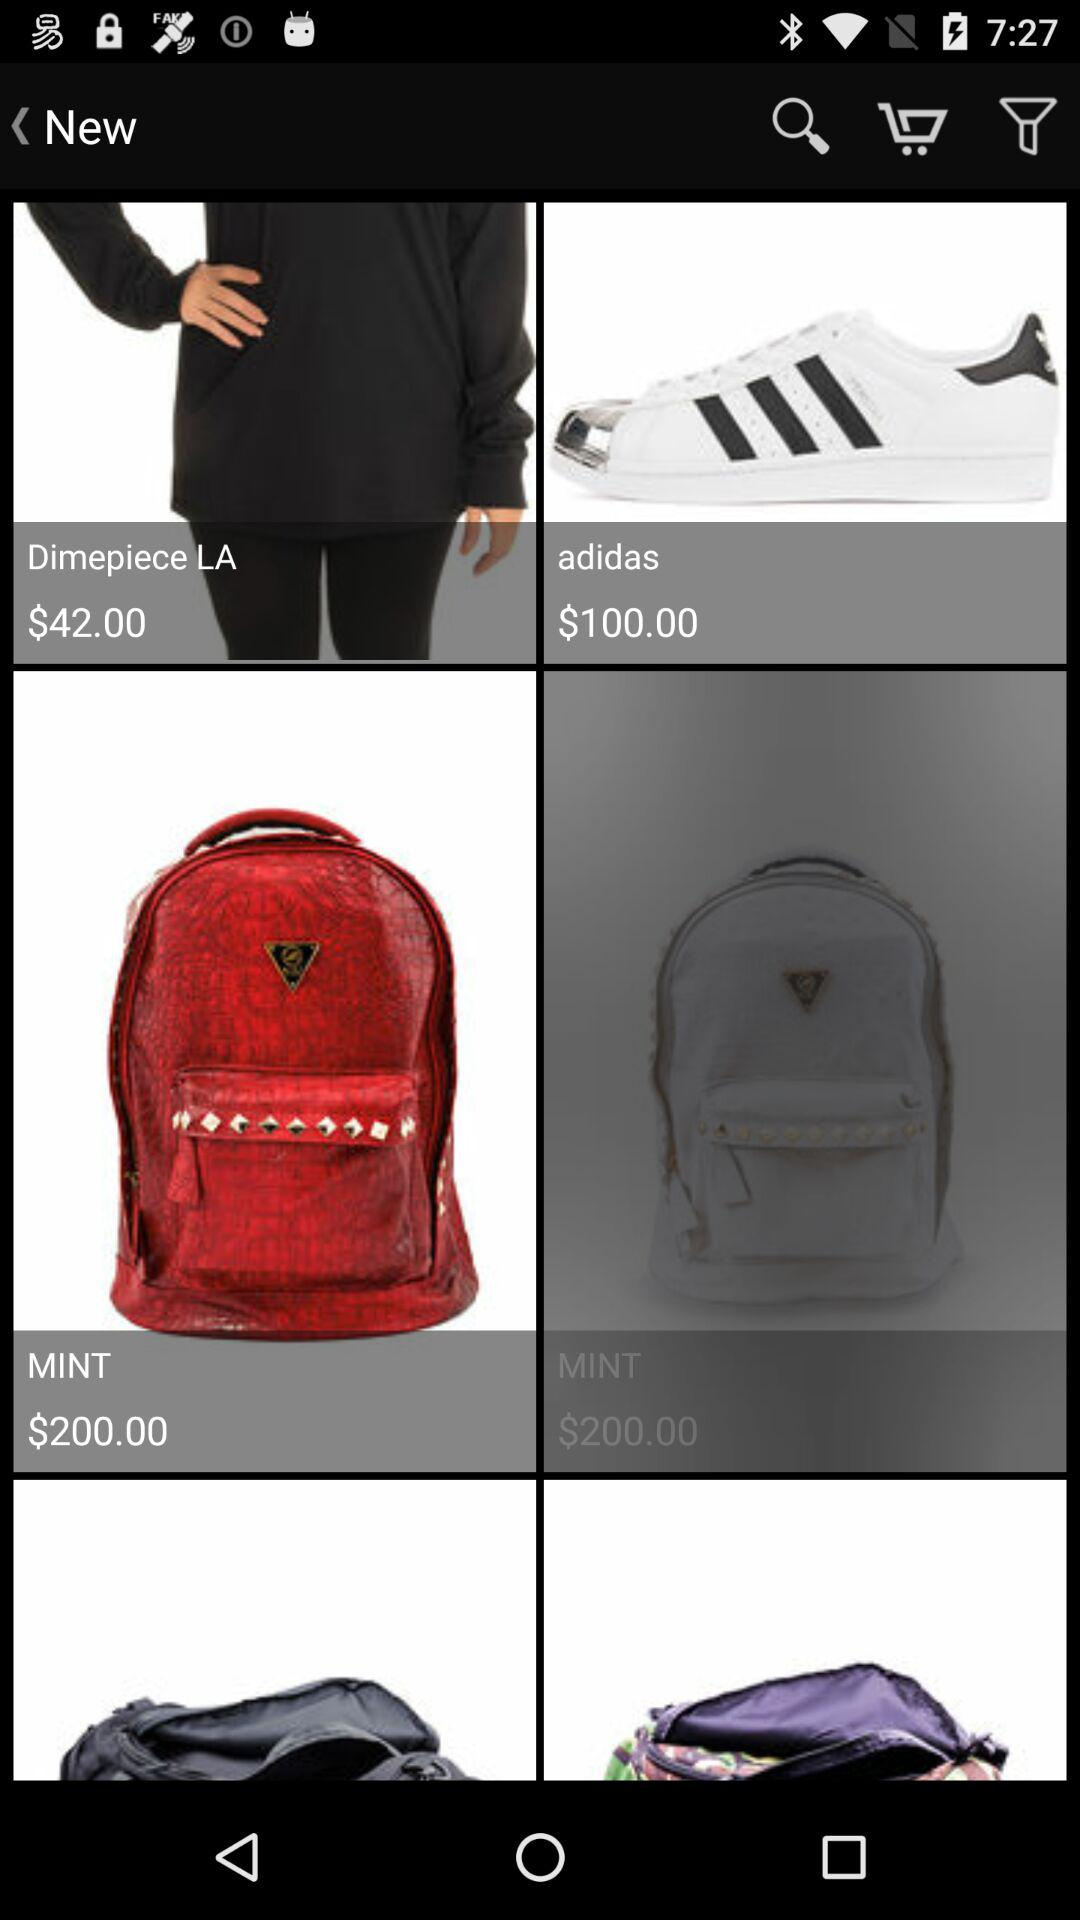What is the "MINT" price? The "MINT" price is 200 dollars. 